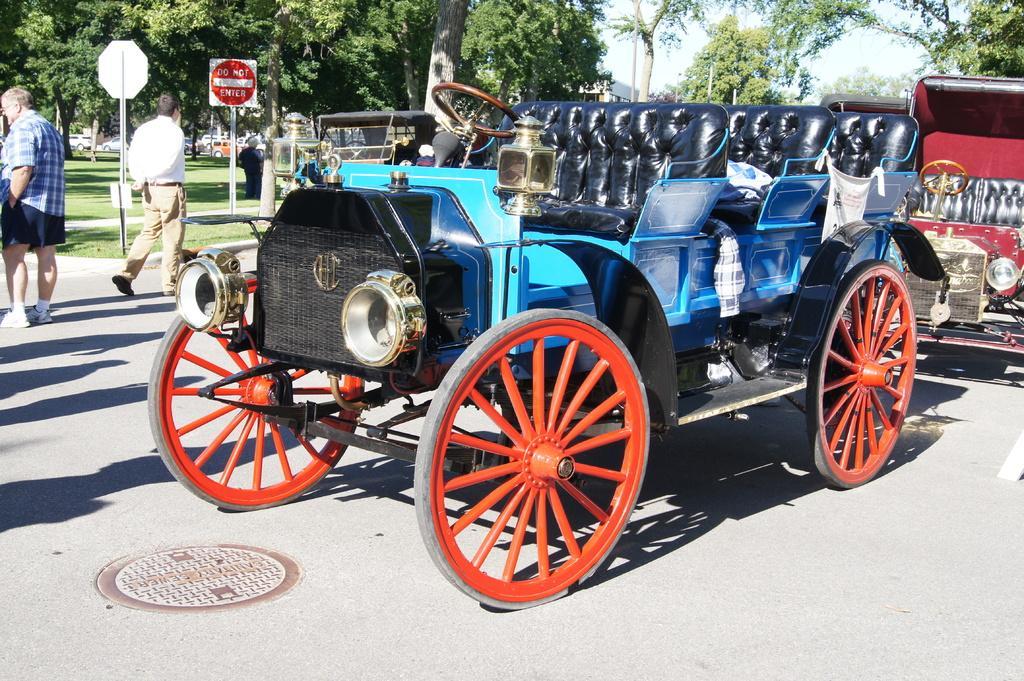Please provide a concise description of this image. There are vehicles and two persons on the road. Here we can see poles, boards, grass, and trees. In the background there is sky. 